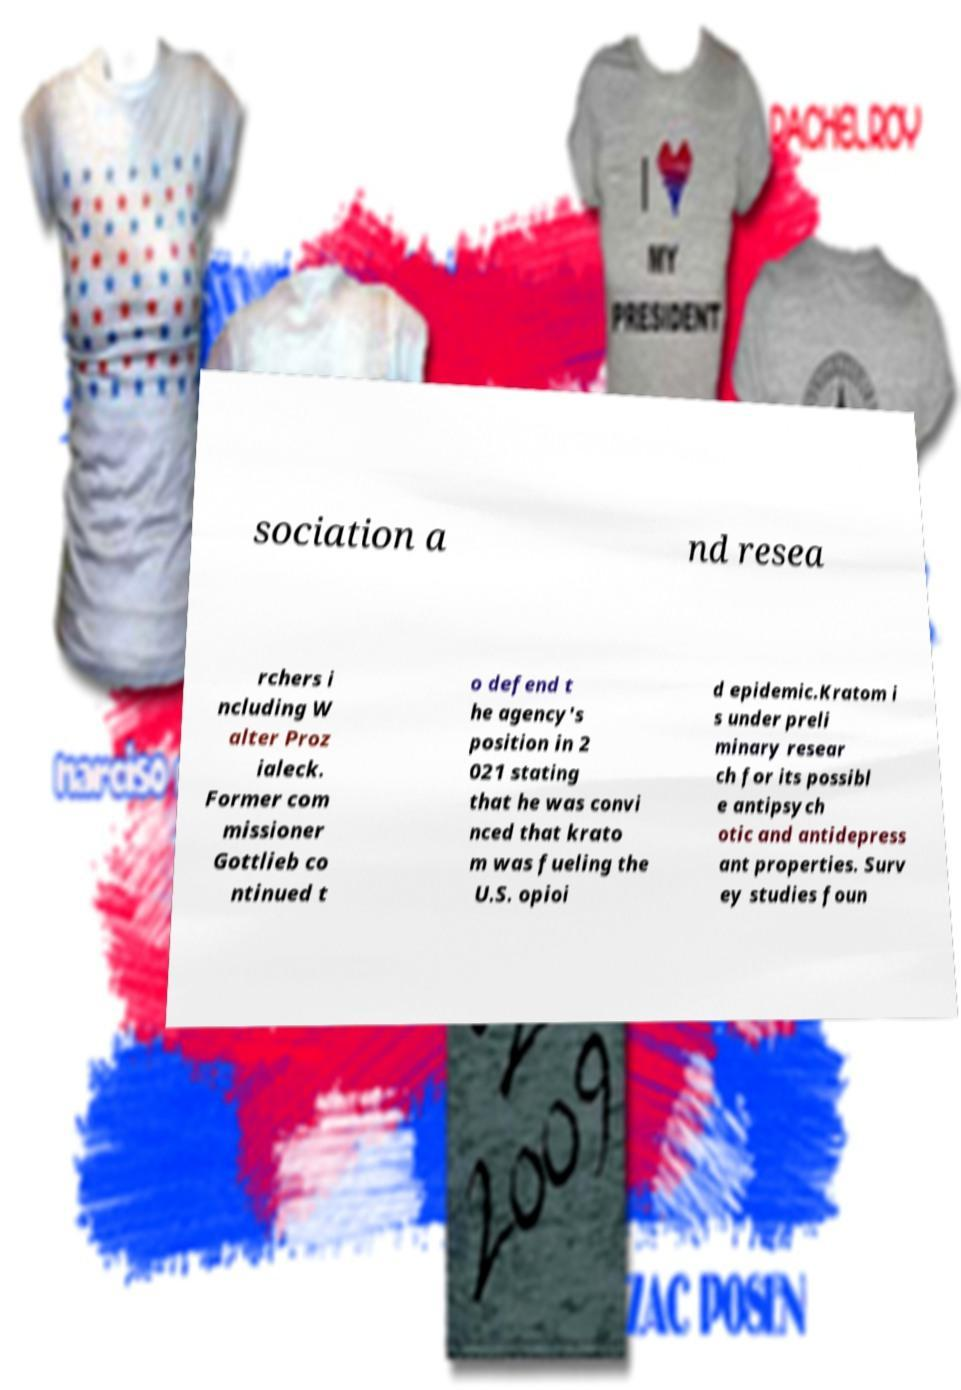I need the written content from this picture converted into text. Can you do that? sociation a nd resea rchers i ncluding W alter Proz ialeck. Former com missioner Gottlieb co ntinued t o defend t he agency's position in 2 021 stating that he was convi nced that krato m was fueling the U.S. opioi d epidemic.Kratom i s under preli minary resear ch for its possibl e antipsych otic and antidepress ant properties. Surv ey studies foun 